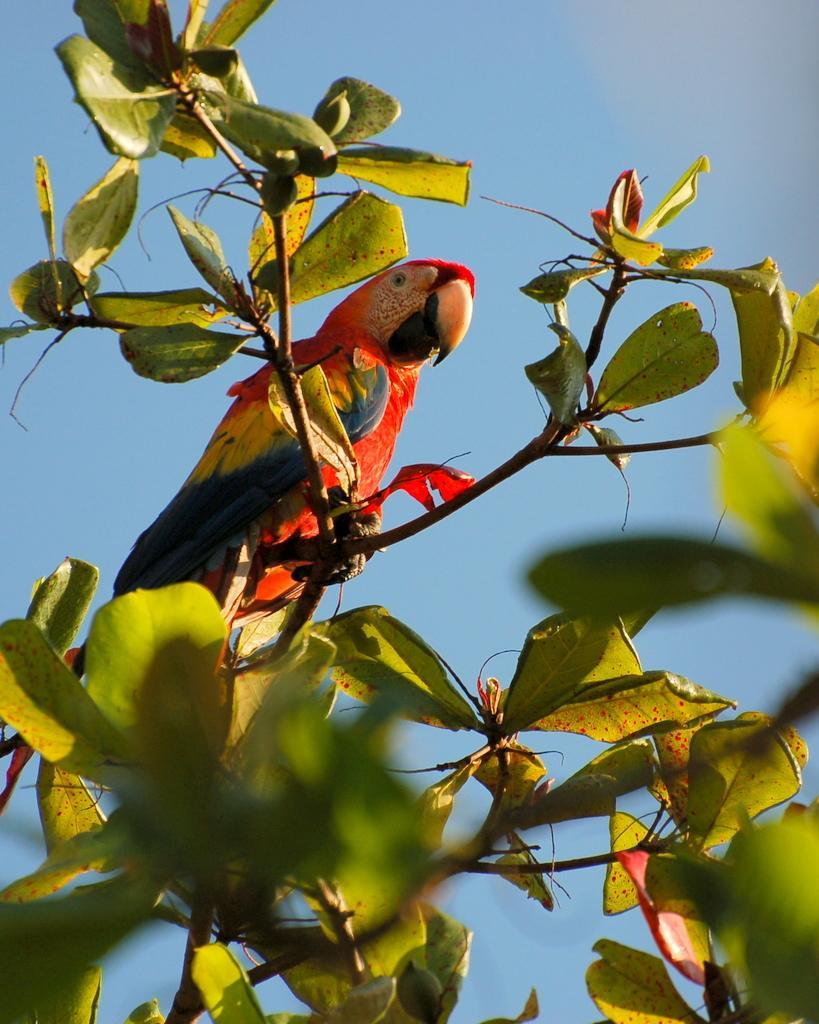Please provide a concise description of this image. In the image there is a tree and there is a bird sitting on the branch of a tree. 